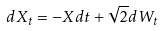<formula> <loc_0><loc_0><loc_500><loc_500>d X _ { t } = - X d t + \sqrt { 2 } d W _ { t }</formula> 